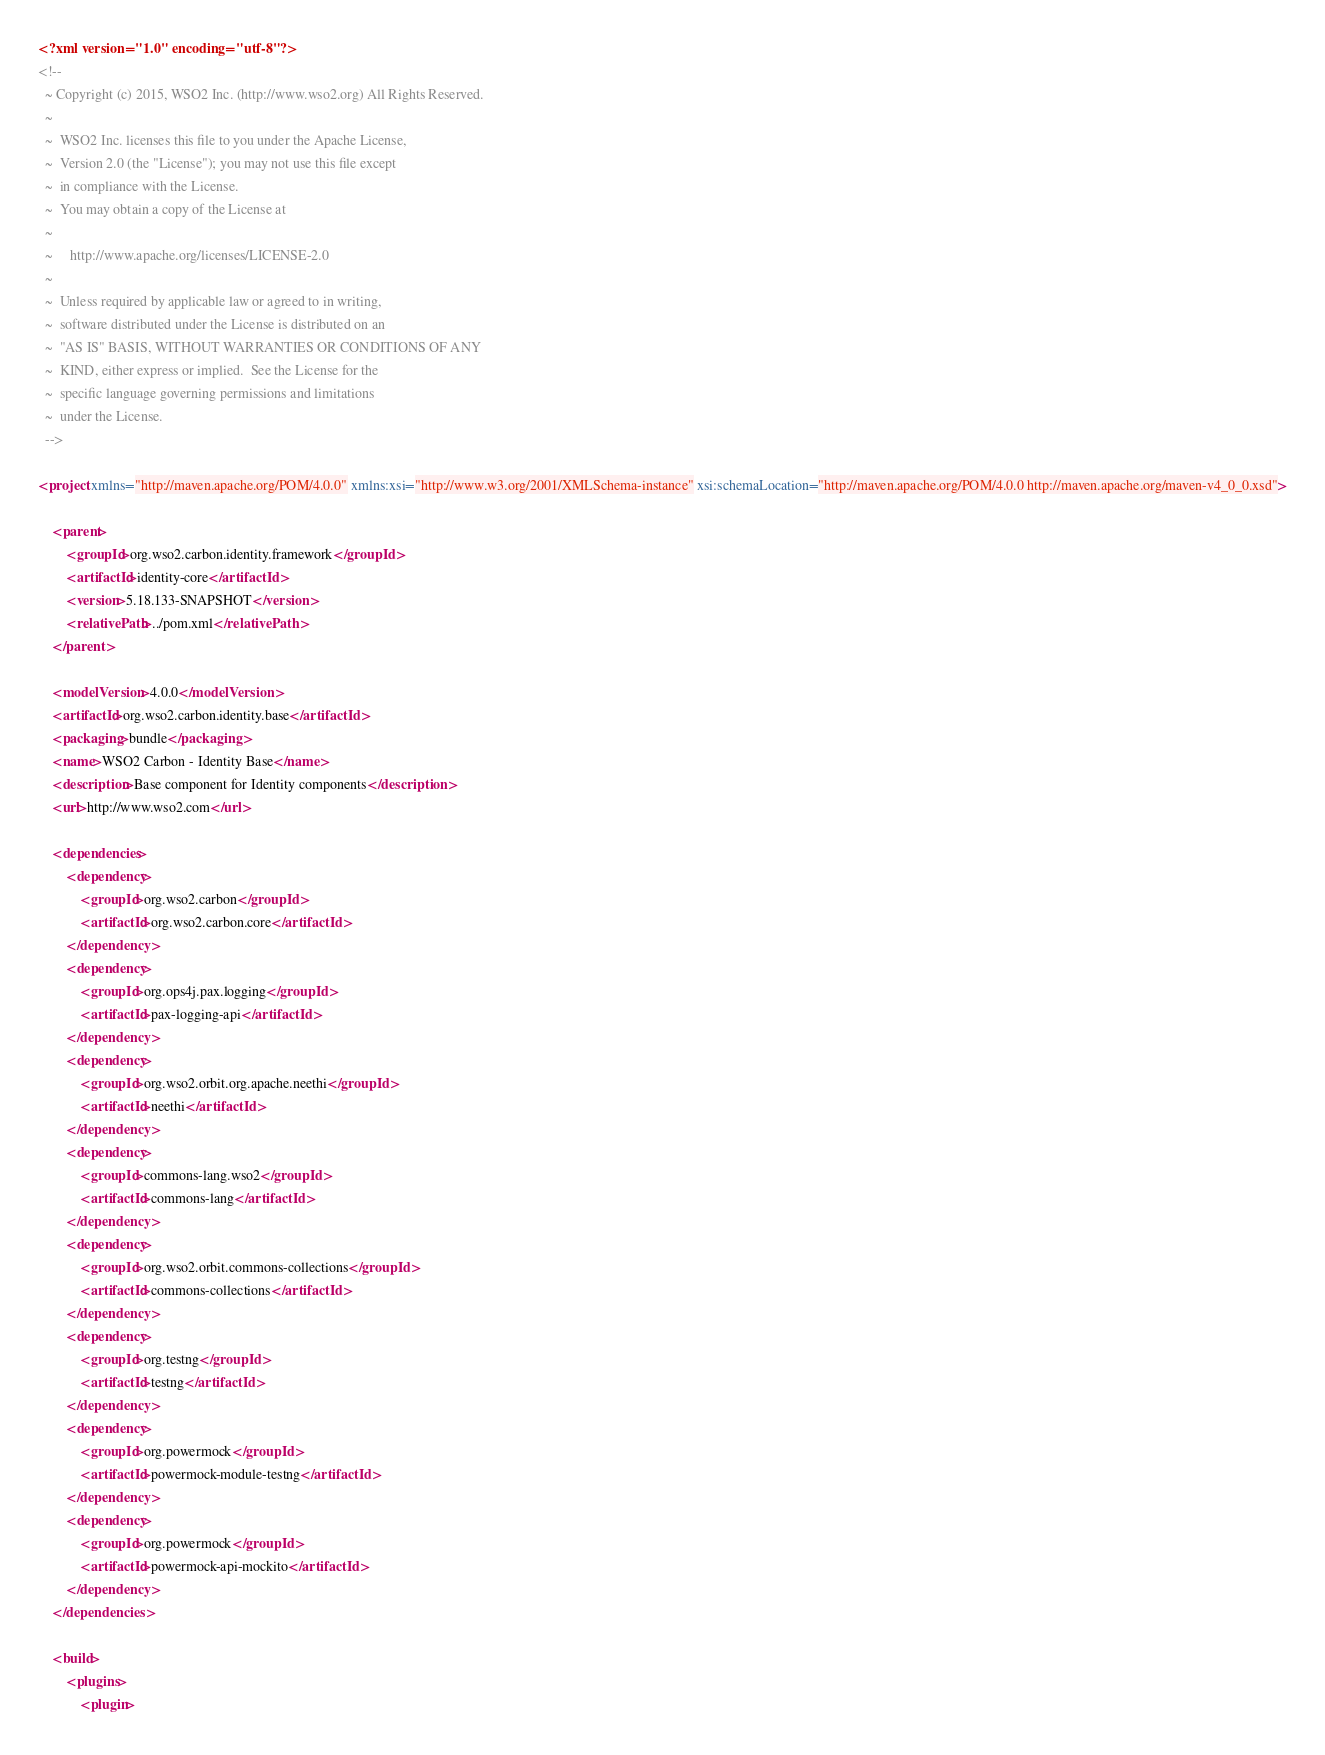Convert code to text. <code><loc_0><loc_0><loc_500><loc_500><_XML_><?xml version="1.0" encoding="utf-8"?>
<!--
  ~ Copyright (c) 2015, WSO2 Inc. (http://www.wso2.org) All Rights Reserved.
  ~
  ~  WSO2 Inc. licenses this file to you under the Apache License,
  ~  Version 2.0 (the "License"); you may not use this file except
  ~  in compliance with the License.
  ~  You may obtain a copy of the License at
  ~
  ~     http://www.apache.org/licenses/LICENSE-2.0
  ~
  ~  Unless required by applicable law or agreed to in writing,
  ~  software distributed under the License is distributed on an
  ~  "AS IS" BASIS, WITHOUT WARRANTIES OR CONDITIONS OF ANY
  ~  KIND, either express or implied.  See the License for the
  ~  specific language governing permissions and limitations
  ~  under the License.
  -->

<project xmlns="http://maven.apache.org/POM/4.0.0" xmlns:xsi="http://www.w3.org/2001/XMLSchema-instance" xsi:schemaLocation="http://maven.apache.org/POM/4.0.0 http://maven.apache.org/maven-v4_0_0.xsd">

    <parent>
        <groupId>org.wso2.carbon.identity.framework</groupId>
        <artifactId>identity-core</artifactId>
        <version>5.18.133-SNAPSHOT</version>
        <relativePath>../pom.xml</relativePath>
    </parent>

    <modelVersion>4.0.0</modelVersion>
    <artifactId>org.wso2.carbon.identity.base</artifactId>
    <packaging>bundle</packaging>
    <name>WSO2 Carbon - Identity Base</name>
    <description>Base component for Identity components</description>
    <url>http://www.wso2.com</url>

    <dependencies>
        <dependency>
            <groupId>org.wso2.carbon</groupId>
            <artifactId>org.wso2.carbon.core</artifactId>
        </dependency>
        <dependency>
            <groupId>org.ops4j.pax.logging</groupId>
            <artifactId>pax-logging-api</artifactId>
        </dependency>
        <dependency>
            <groupId>org.wso2.orbit.org.apache.neethi</groupId>
            <artifactId>neethi</artifactId>
        </dependency>
        <dependency>
            <groupId>commons-lang.wso2</groupId>
            <artifactId>commons-lang</artifactId>
        </dependency>
        <dependency>
            <groupId>org.wso2.orbit.commons-collections</groupId>
            <artifactId>commons-collections</artifactId>
        </dependency>
        <dependency>
            <groupId>org.testng</groupId>
            <artifactId>testng</artifactId>
        </dependency>
        <dependency>
            <groupId>org.powermock</groupId>
            <artifactId>powermock-module-testng</artifactId>
        </dependency>
        <dependency>
            <groupId>org.powermock</groupId>
            <artifactId>powermock-api-mockito</artifactId>
        </dependency>
    </dependencies>

    <build>
        <plugins>
            <plugin></code> 